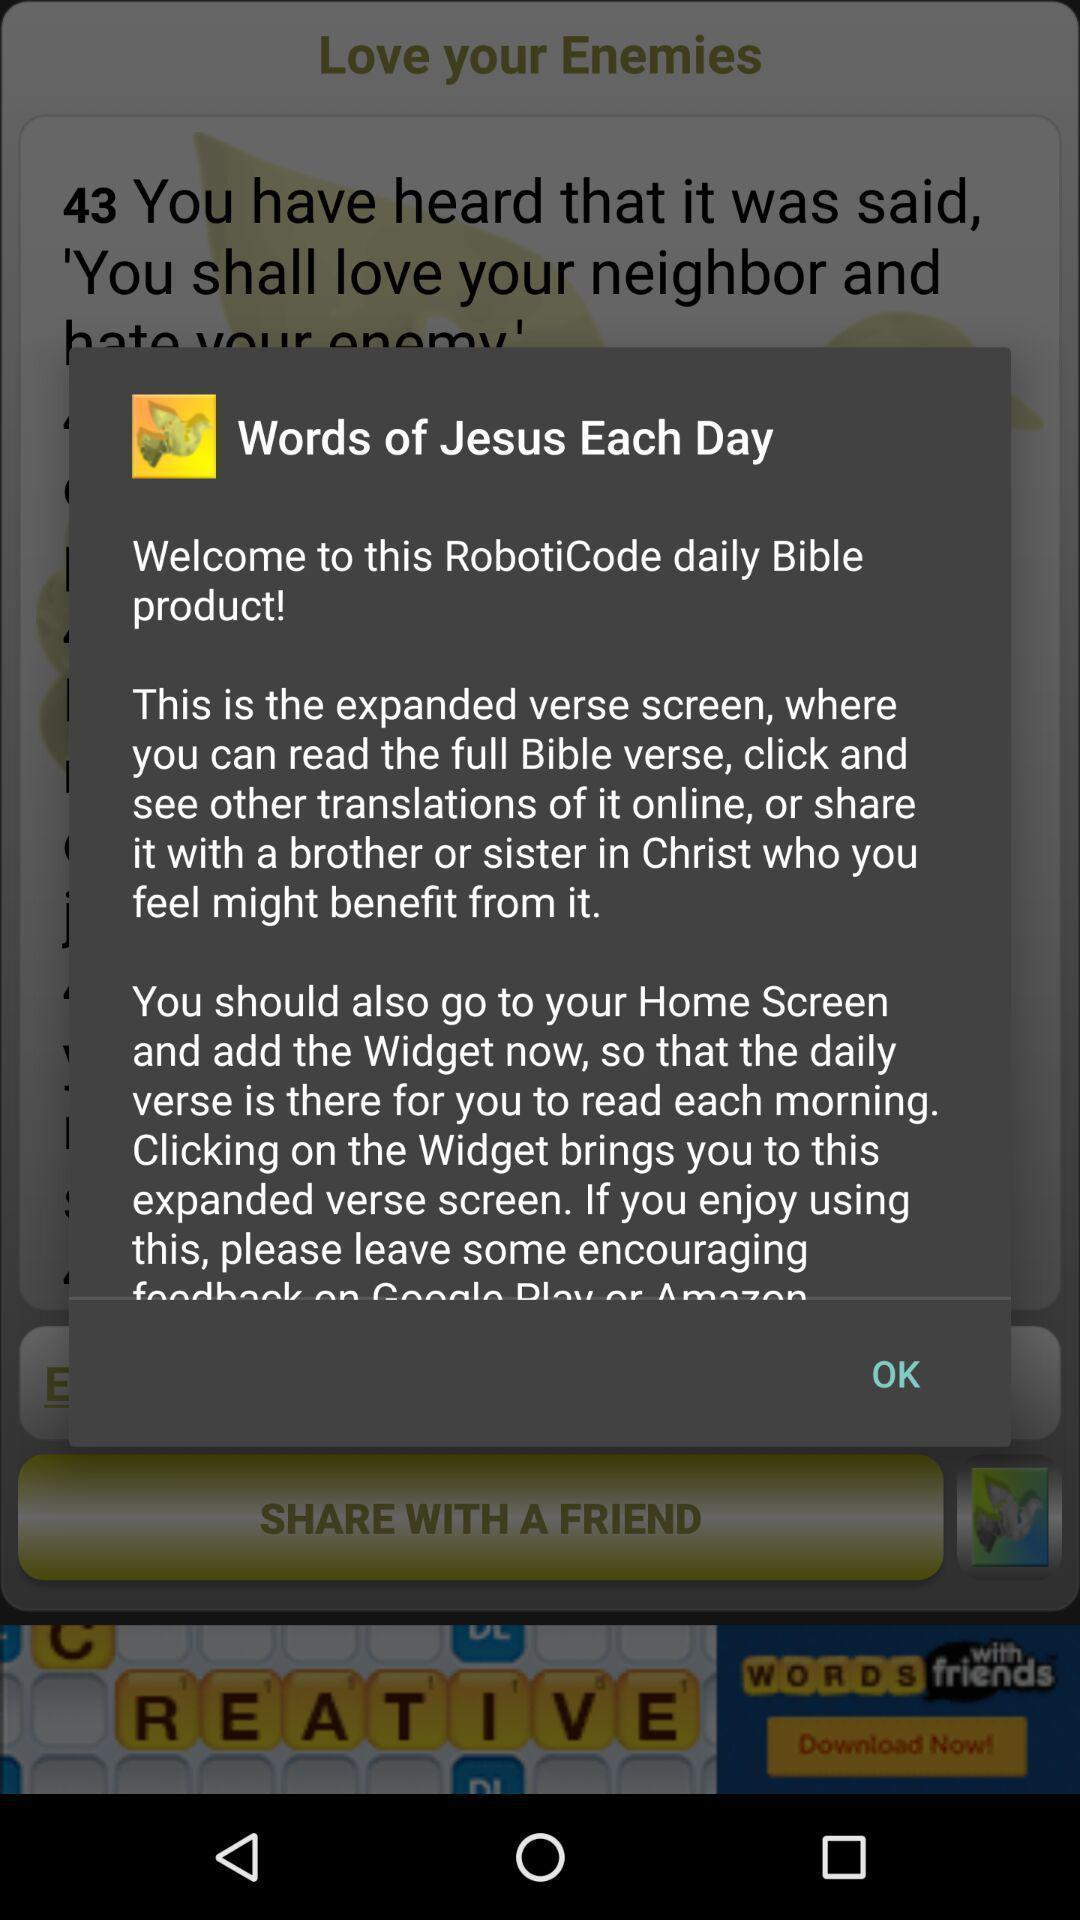Provide a description of this screenshot. Popup showing message of the day in holy-book app. 